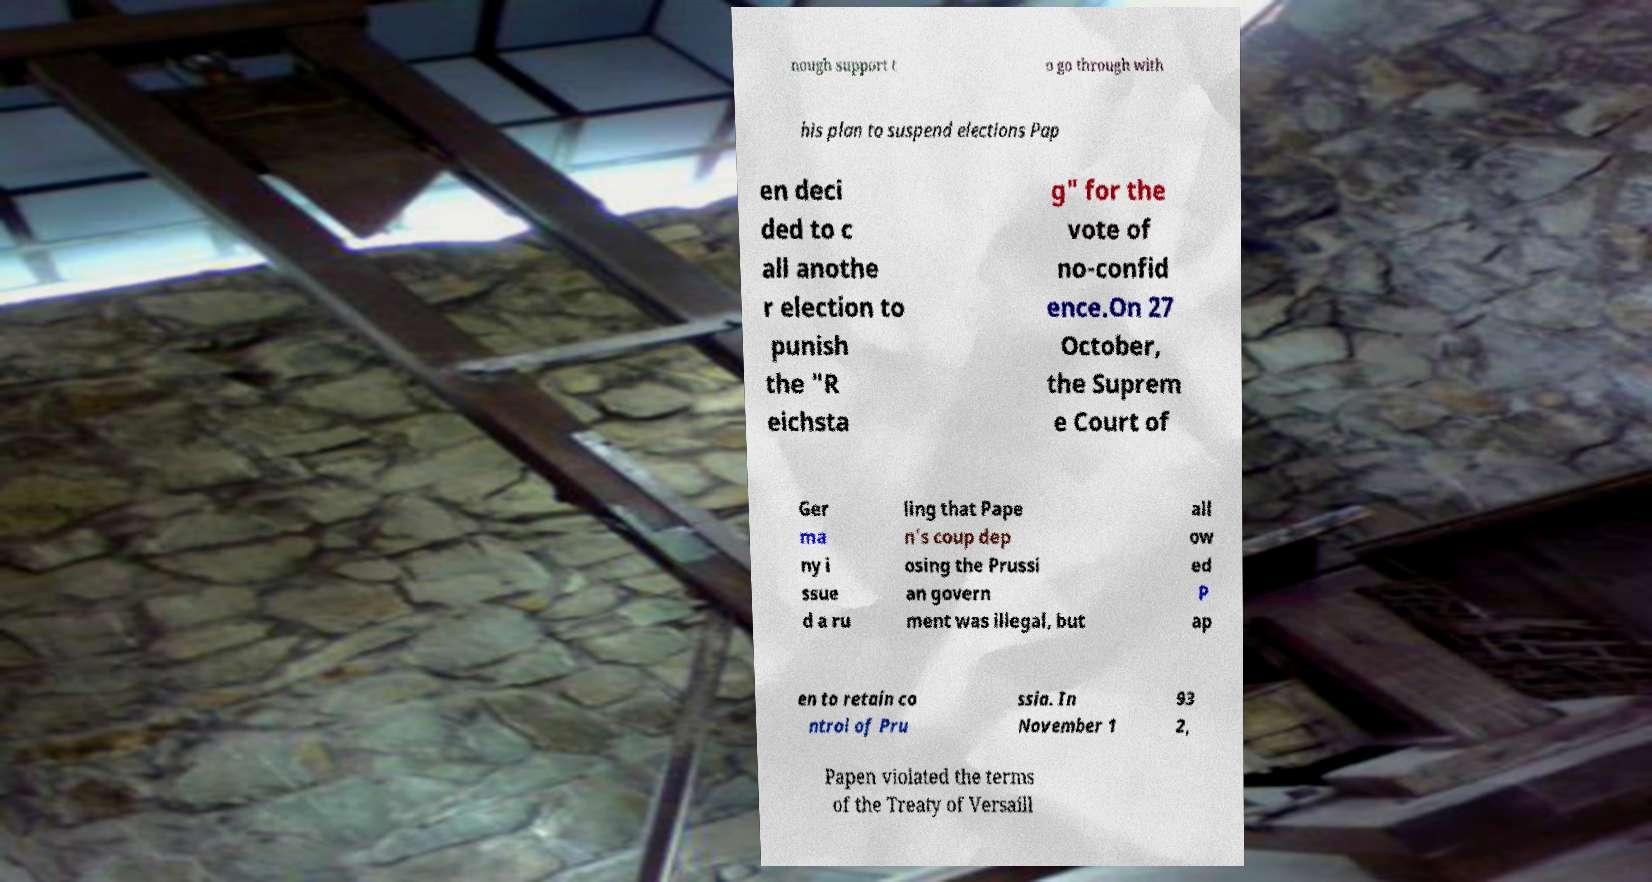Could you extract and type out the text from this image? nough support t o go through with his plan to suspend elections Pap en deci ded to c all anothe r election to punish the "R eichsta g" for the vote of no-confid ence.On 27 October, the Suprem e Court of Ger ma ny i ssue d a ru ling that Pape n's coup dep osing the Prussi an govern ment was illegal, but all ow ed P ap en to retain co ntrol of Pru ssia. In November 1 93 2, Papen violated the terms of the Treaty of Versaill 